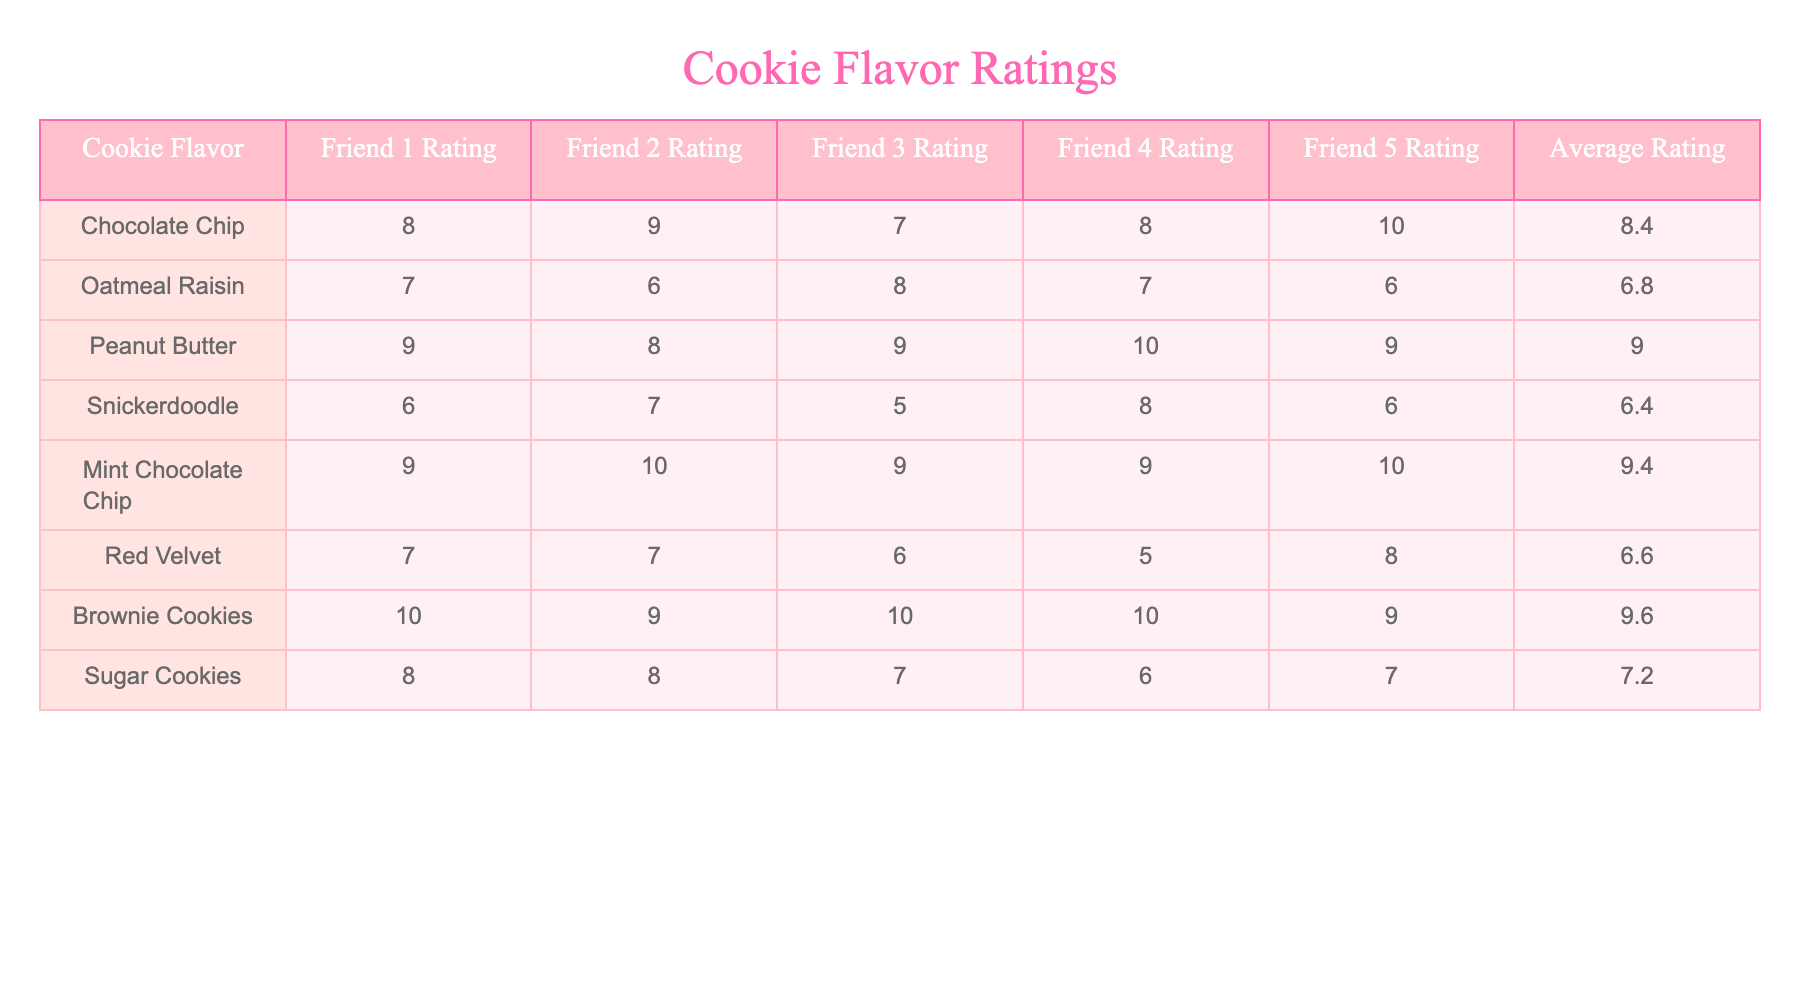What is the average rating of the Peanut Butter cookies? To find the average rating of Peanut Butter cookies, we look at the column for Peanut Butter and see the ratings: 9, 8, 9, 10, and 9. We add these together: 9 + 8 + 9 + 10 + 9 = 45. Since there are 5 ratings, we divide this sum by 5, resulting in 45 / 5 = 9.
Answer: 9 Which cookie flavor received the highest rating from friend 3? Looking at the ratings given by friend 3, we see the ratings for each cookie flavor: 7 (Chocolate Chip), 8 (Oatmeal Raisin), 9 (Peanut Butter), 5 (Snickerdoodle), 9 (Mint Chocolate Chip), 6 (Red Velvet), 10 (Brownie Cookies), and 7 (Sugar Cookies). The highest rating is 10, which corresponds to Brownie Cookies.
Answer: Brownie Cookies Did any cookie flavor receive an average rating of 6 or below? We examine each cookie's average rating from the table. The flavors and their average ratings are: Chocolate Chip (8.4), Oatmeal Raisin (6.8), Peanut Butter (9.0), Snickerdoodle (6.4), Mint Chocolate Chip (9.4), Red Velvet (6.6), Brownie Cookies (9.6), and Sugar Cookies (7.2). The only flavors that have an average rating of 6 or below are Oatmeal Raisin (6.8) and Snickerdoodle (6.4), confirming that at least one flavor does.
Answer: Yes What is the difference between the highest and lowest average ratings among the cookie flavors? First, we identify the highest and lowest average ratings from the table. The highest average rating is 9.6 (Brownie Cookies) and the lowest is 6.4 (Snickerdoodle). The difference is 9.6 - 6.4 = 3.2.
Answer: 3.2 Which friend gave the lowest rating to Chocolate Chip cookies? We review the ratings for Chocolate Chip cookies: Friend 1 (8), Friend 2 (9), Friend 3 (7), Friend 4 (8), and Friend 5 (10). The lowest rating among these is 7, which is given by Friend 3.
Answer: Friend 3 